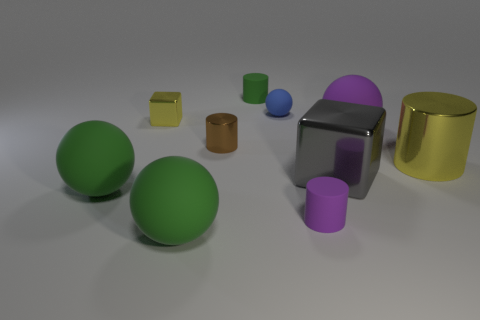There is a sphere behind the purple sphere; does it have the same color as the cylinder in front of the large gray metal block? No, the sphere behind the purple sphere does not have the same color as the cylinder in front of the large gray metal block. The sphere in the back is green, while the cylinder in the front is blue. 